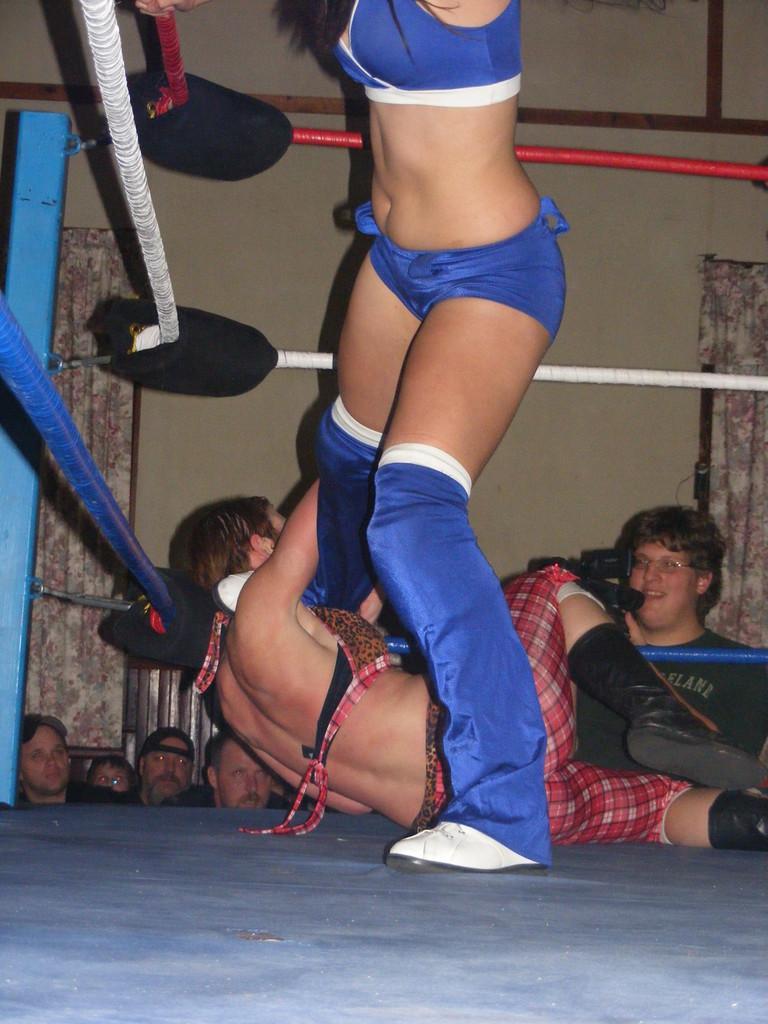Describe this image in one or two sentences. In this image we can see two people fighting in a ring. Behind the persons we can see a group of persons, wall and curtains. On the right side a person is holding a video cam. 